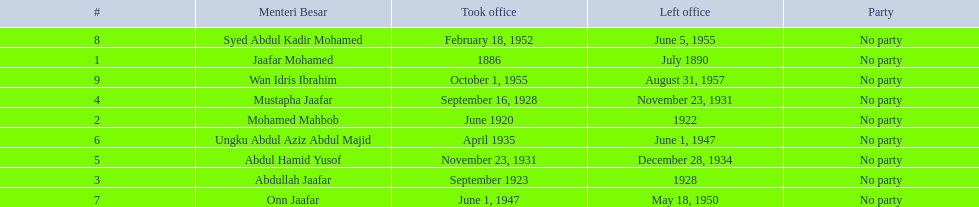Name someone who was not in office more than 4 years. Mohamed Mahbob. 